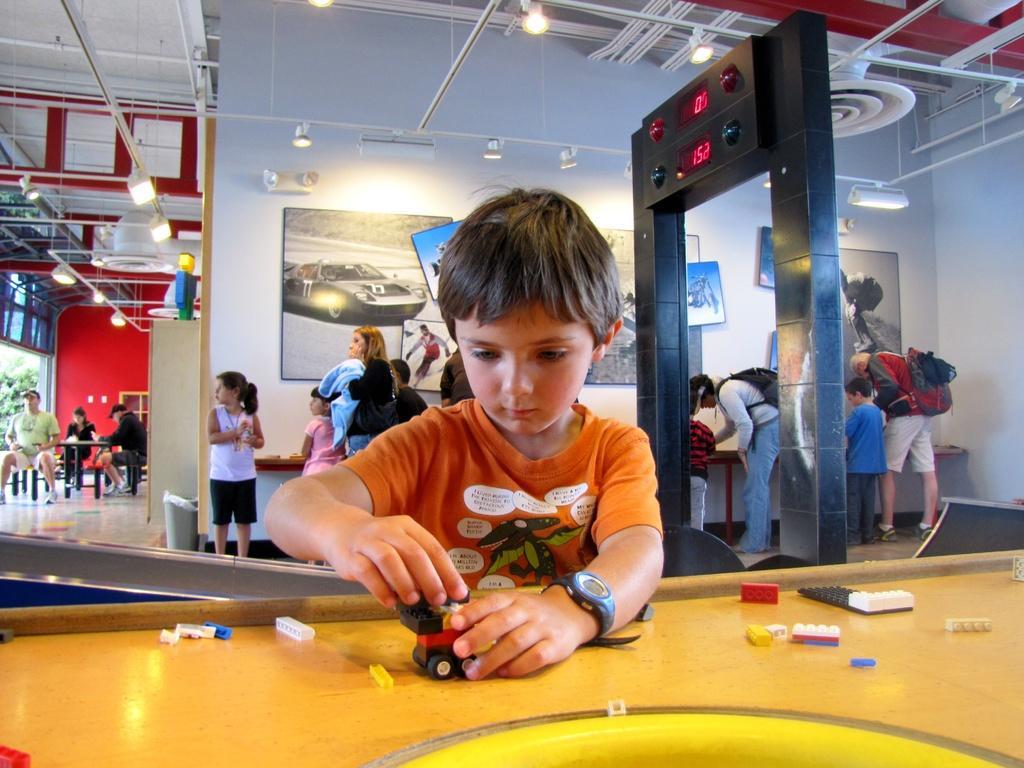Please provide a concise description of this image. This kid is playing with toys. On this table there are toys. Few persons are standing and few persons are sitting on a chair. A picture on wall. On top there are lights. This is tree. This is an electronic device. These persons wore bags. 